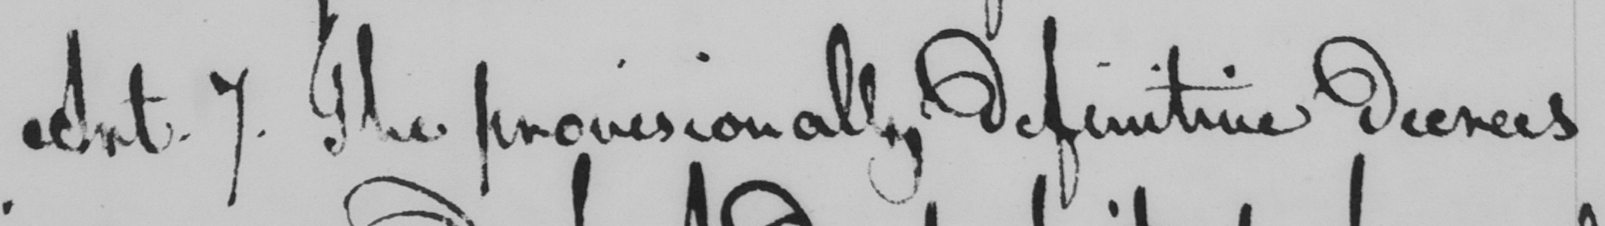Can you tell me what this handwritten text says? Art . 7 . The provisionally definitive decrees 